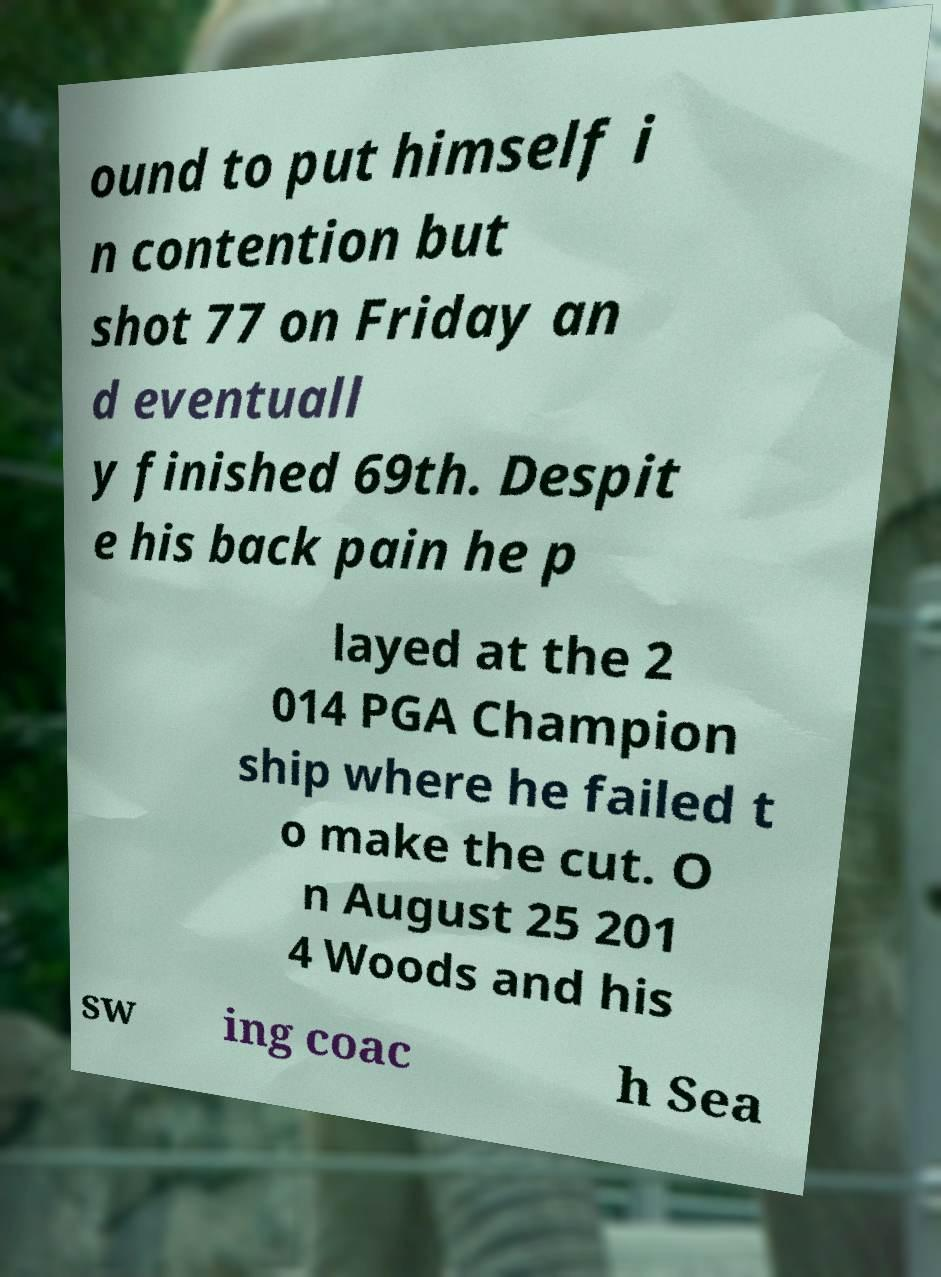I need the written content from this picture converted into text. Can you do that? ound to put himself i n contention but shot 77 on Friday an d eventuall y finished 69th. Despit e his back pain he p layed at the 2 014 PGA Champion ship where he failed t o make the cut. O n August 25 201 4 Woods and his sw ing coac h Sea 